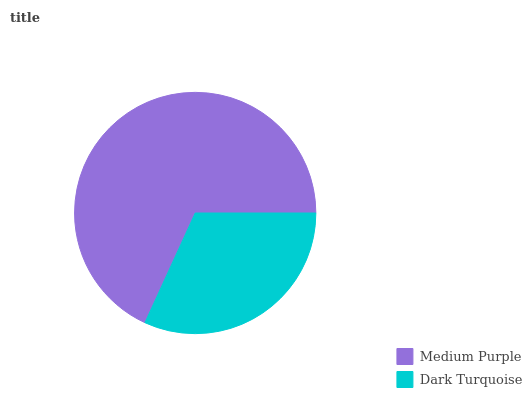Is Dark Turquoise the minimum?
Answer yes or no. Yes. Is Medium Purple the maximum?
Answer yes or no. Yes. Is Dark Turquoise the maximum?
Answer yes or no. No. Is Medium Purple greater than Dark Turquoise?
Answer yes or no. Yes. Is Dark Turquoise less than Medium Purple?
Answer yes or no. Yes. Is Dark Turquoise greater than Medium Purple?
Answer yes or no. No. Is Medium Purple less than Dark Turquoise?
Answer yes or no. No. Is Medium Purple the high median?
Answer yes or no. Yes. Is Dark Turquoise the low median?
Answer yes or no. Yes. Is Dark Turquoise the high median?
Answer yes or no. No. Is Medium Purple the low median?
Answer yes or no. No. 